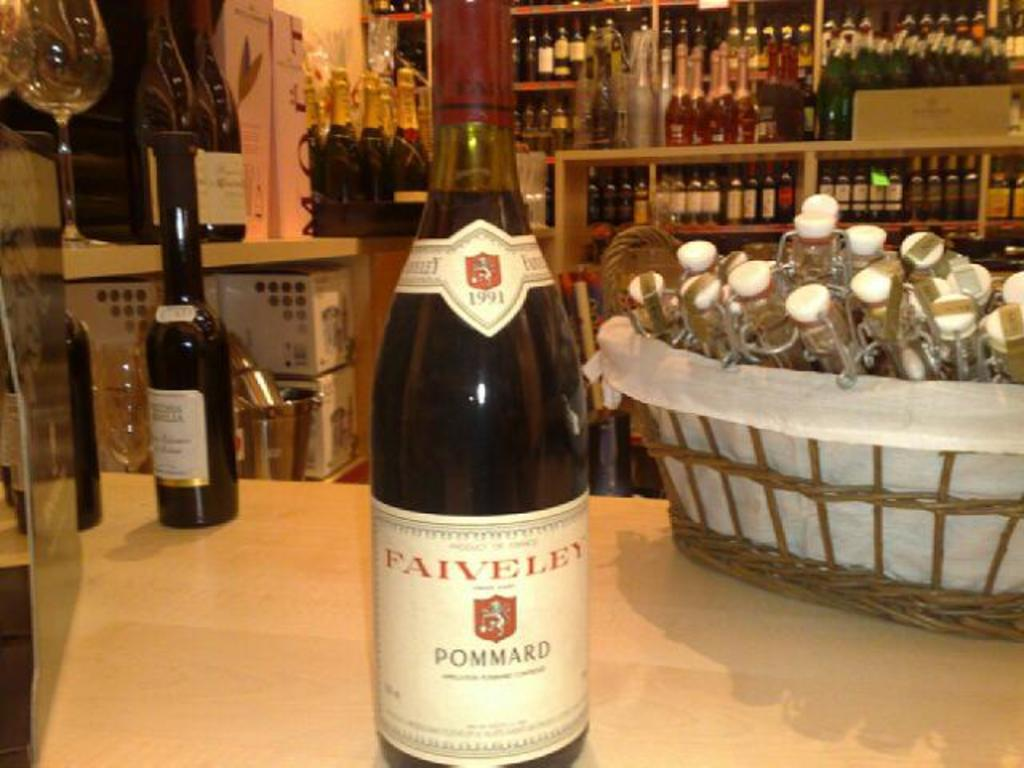<image>
Share a concise interpretation of the image provided. A bottle of wine from the brand Faiveley. 